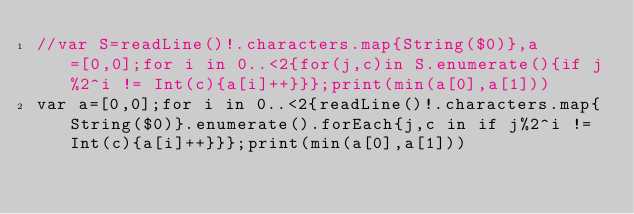<code> <loc_0><loc_0><loc_500><loc_500><_Swift_>//var S=readLine()!.characters.map{String($0)},a=[0,0];for i in 0..<2{for(j,c)in S.enumerate(){if j%2^i != Int(c){a[i]++}}};print(min(a[0],a[1]))
var a=[0,0];for i in 0..<2{readLine()!.characters.map{String($0)}.enumerate().forEach{j,c in if j%2^i != Int(c){a[i]++}}};print(min(a[0],a[1]))</code> 